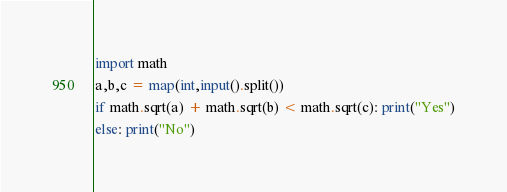Convert code to text. <code><loc_0><loc_0><loc_500><loc_500><_Python_>import math
a,b,c = map(int,input().split())
if math.sqrt(a) + math.sqrt(b) < math.sqrt(c): print("Yes")
else: print("No")</code> 